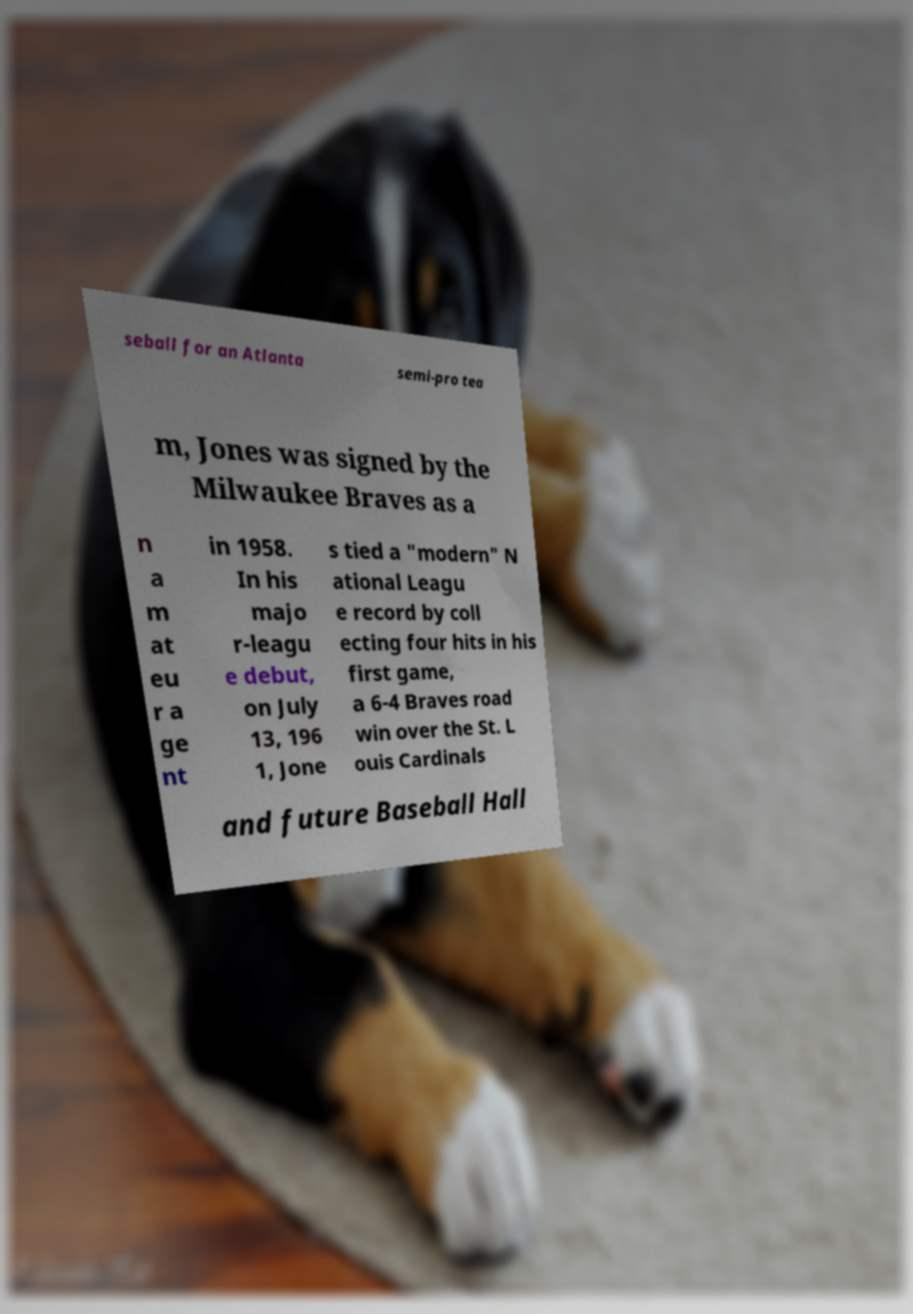Please identify and transcribe the text found in this image. seball for an Atlanta semi-pro tea m, Jones was signed by the Milwaukee Braves as a n a m at eu r a ge nt in 1958. In his majo r-leagu e debut, on July 13, 196 1, Jone s tied a "modern" N ational Leagu e record by coll ecting four hits in his first game, a 6-4 Braves road win over the St. L ouis Cardinals and future Baseball Hall 